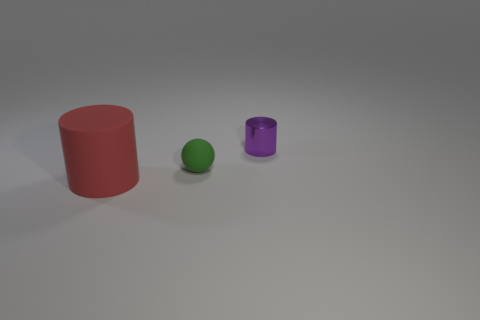Subtract 1 spheres. How many spheres are left? 0 Subtract all purple balls. Subtract all gray cylinders. How many balls are left? 1 Subtract all blue spheres. How many brown cylinders are left? 0 Subtract all green rubber objects. Subtract all rubber balls. How many objects are left? 1 Add 2 green things. How many green things are left? 3 Add 1 yellow cubes. How many yellow cubes exist? 1 Add 1 tiny purple metallic cubes. How many objects exist? 4 Subtract all red cylinders. How many cylinders are left? 1 Subtract 0 purple spheres. How many objects are left? 3 Subtract all cylinders. How many objects are left? 1 